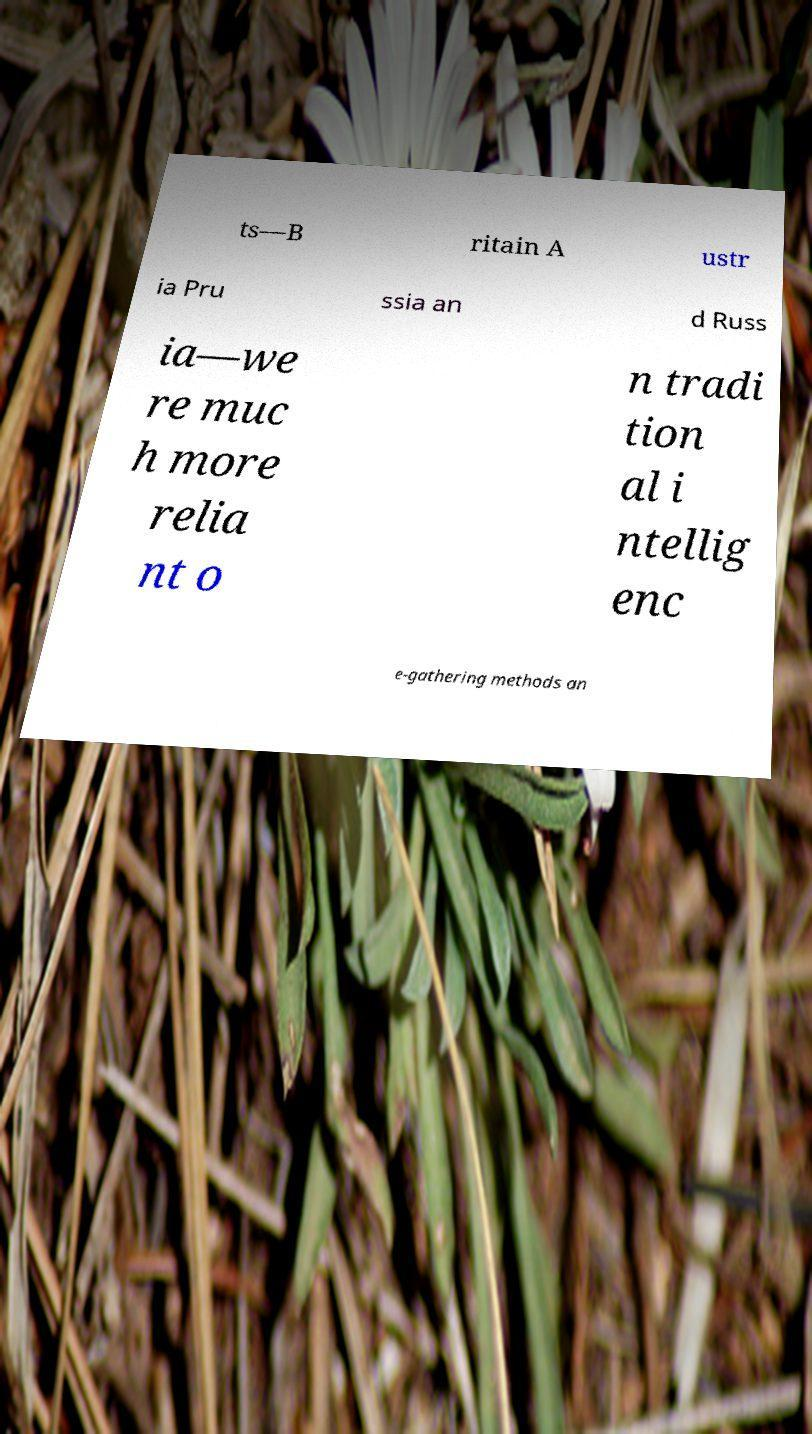I need the written content from this picture converted into text. Can you do that? ts—B ritain A ustr ia Pru ssia an d Russ ia—we re muc h more relia nt o n tradi tion al i ntellig enc e-gathering methods an 